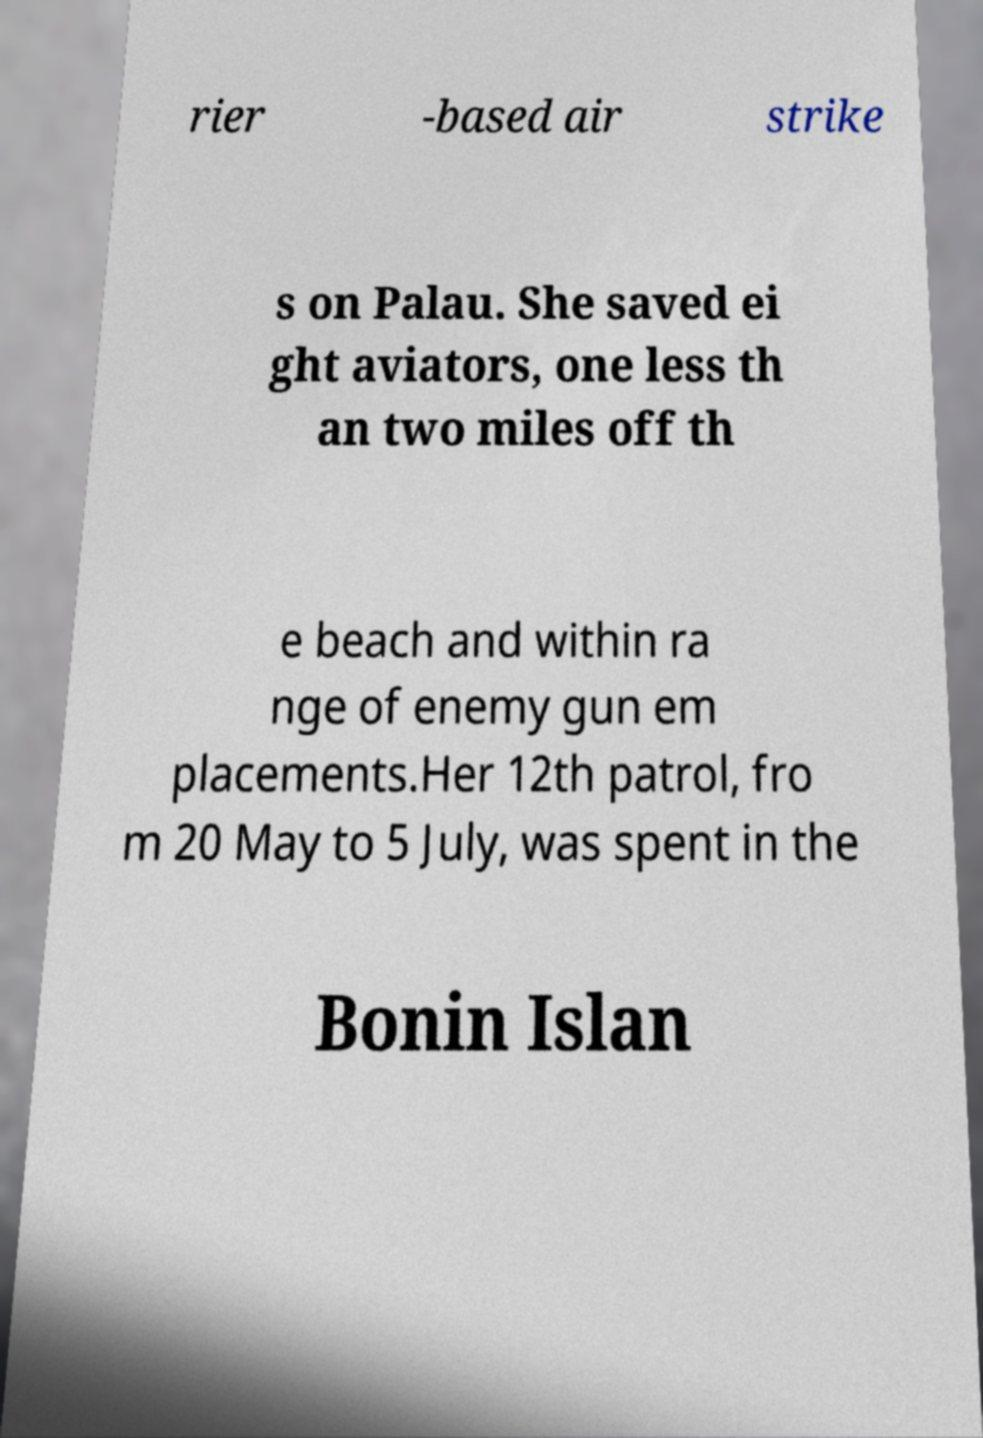Please identify and transcribe the text found in this image. rier -based air strike s on Palau. She saved ei ght aviators, one less th an two miles off th e beach and within ra nge of enemy gun em placements.Her 12th patrol, fro m 20 May to 5 July, was spent in the Bonin Islan 